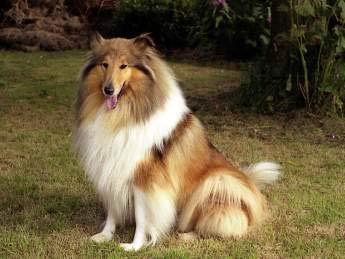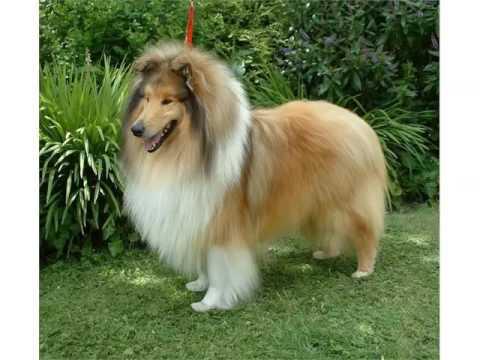The first image is the image on the left, the second image is the image on the right. Considering the images on both sides, is "The dog in one of the images is sitting and looking toward the camera." valid? Answer yes or no. Yes. 